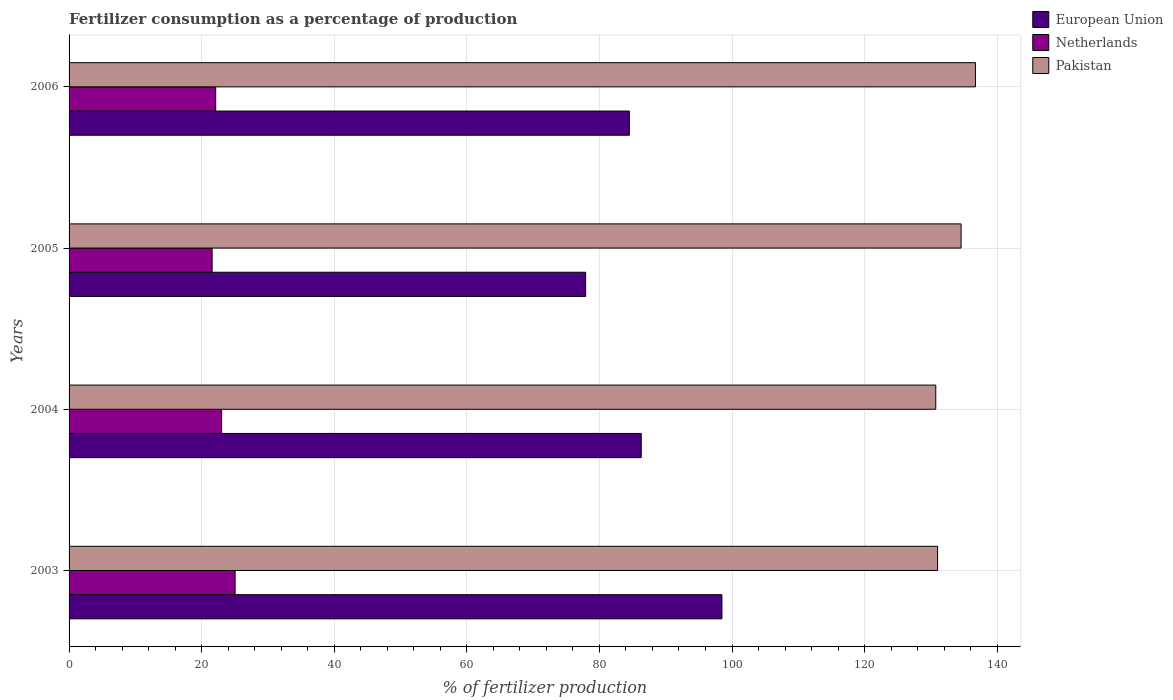How many different coloured bars are there?
Keep it short and to the point. 3. How many groups of bars are there?
Keep it short and to the point. 4. Are the number of bars per tick equal to the number of legend labels?
Provide a succinct answer. Yes. How many bars are there on the 2nd tick from the top?
Ensure brevity in your answer.  3. How many bars are there on the 2nd tick from the bottom?
Ensure brevity in your answer.  3. What is the label of the 2nd group of bars from the top?
Provide a short and direct response. 2005. In how many cases, is the number of bars for a given year not equal to the number of legend labels?
Your response must be concise. 0. What is the percentage of fertilizers consumed in European Union in 2005?
Your response must be concise. 77.92. Across all years, what is the maximum percentage of fertilizers consumed in European Union?
Offer a terse response. 98.48. Across all years, what is the minimum percentage of fertilizers consumed in Netherlands?
Offer a terse response. 21.58. In which year was the percentage of fertilizers consumed in Pakistan maximum?
Provide a succinct answer. 2006. In which year was the percentage of fertilizers consumed in Pakistan minimum?
Your response must be concise. 2004. What is the total percentage of fertilizers consumed in Pakistan in the graph?
Your response must be concise. 533.02. What is the difference between the percentage of fertilizers consumed in Netherlands in 2003 and that in 2004?
Your answer should be very brief. 2.04. What is the difference between the percentage of fertilizers consumed in Netherlands in 2005 and the percentage of fertilizers consumed in European Union in 2003?
Your answer should be compact. -76.9. What is the average percentage of fertilizers consumed in Pakistan per year?
Give a very brief answer. 133.26. In the year 2004, what is the difference between the percentage of fertilizers consumed in Pakistan and percentage of fertilizers consumed in European Union?
Make the answer very short. 44.43. What is the ratio of the percentage of fertilizers consumed in Pakistan in 2003 to that in 2006?
Your answer should be compact. 0.96. Is the percentage of fertilizers consumed in Pakistan in 2004 less than that in 2006?
Give a very brief answer. Yes. Is the difference between the percentage of fertilizers consumed in Pakistan in 2005 and 2006 greater than the difference between the percentage of fertilizers consumed in European Union in 2005 and 2006?
Offer a very short reply. Yes. What is the difference between the highest and the second highest percentage of fertilizers consumed in Pakistan?
Provide a short and direct response. 2.16. What is the difference between the highest and the lowest percentage of fertilizers consumed in Pakistan?
Make the answer very short. 5.99. In how many years, is the percentage of fertilizers consumed in Netherlands greater than the average percentage of fertilizers consumed in Netherlands taken over all years?
Your answer should be compact. 2. What does the 1st bar from the bottom in 2006 represents?
Provide a succinct answer. European Union. Are all the bars in the graph horizontal?
Offer a terse response. Yes. How many years are there in the graph?
Your answer should be very brief. 4. Does the graph contain any zero values?
Give a very brief answer. No. How are the legend labels stacked?
Provide a succinct answer. Vertical. What is the title of the graph?
Offer a terse response. Fertilizer consumption as a percentage of production. What is the label or title of the X-axis?
Offer a very short reply. % of fertilizer production. What is the % of fertilizer production of European Union in 2003?
Provide a short and direct response. 98.48. What is the % of fertilizer production in Netherlands in 2003?
Your answer should be very brief. 25.04. What is the % of fertilizer production of Pakistan in 2003?
Your answer should be very brief. 131.01. What is the % of fertilizer production in European Union in 2004?
Offer a terse response. 86.31. What is the % of fertilizer production in Netherlands in 2004?
Your response must be concise. 23.01. What is the % of fertilizer production of Pakistan in 2004?
Make the answer very short. 130.73. What is the % of fertilizer production in European Union in 2005?
Keep it short and to the point. 77.92. What is the % of fertilizer production in Netherlands in 2005?
Your response must be concise. 21.58. What is the % of fertilizer production of Pakistan in 2005?
Ensure brevity in your answer.  134.56. What is the % of fertilizer production in European Union in 2006?
Give a very brief answer. 84.51. What is the % of fertilizer production of Netherlands in 2006?
Offer a very short reply. 22.12. What is the % of fertilizer production in Pakistan in 2006?
Offer a terse response. 136.72. Across all years, what is the maximum % of fertilizer production of European Union?
Your answer should be very brief. 98.48. Across all years, what is the maximum % of fertilizer production of Netherlands?
Your response must be concise. 25.04. Across all years, what is the maximum % of fertilizer production in Pakistan?
Keep it short and to the point. 136.72. Across all years, what is the minimum % of fertilizer production of European Union?
Give a very brief answer. 77.92. Across all years, what is the minimum % of fertilizer production in Netherlands?
Provide a succinct answer. 21.58. Across all years, what is the minimum % of fertilizer production in Pakistan?
Ensure brevity in your answer.  130.73. What is the total % of fertilizer production in European Union in the graph?
Provide a succinct answer. 347.22. What is the total % of fertilizer production of Netherlands in the graph?
Provide a succinct answer. 91.75. What is the total % of fertilizer production in Pakistan in the graph?
Offer a very short reply. 533.02. What is the difference between the % of fertilizer production of European Union in 2003 and that in 2004?
Provide a succinct answer. 12.17. What is the difference between the % of fertilizer production in Netherlands in 2003 and that in 2004?
Give a very brief answer. 2.04. What is the difference between the % of fertilizer production in Pakistan in 2003 and that in 2004?
Offer a terse response. 0.28. What is the difference between the % of fertilizer production of European Union in 2003 and that in 2005?
Give a very brief answer. 20.56. What is the difference between the % of fertilizer production in Netherlands in 2003 and that in 2005?
Your answer should be very brief. 3.47. What is the difference between the % of fertilizer production of Pakistan in 2003 and that in 2005?
Your response must be concise. -3.55. What is the difference between the % of fertilizer production in European Union in 2003 and that in 2006?
Make the answer very short. 13.97. What is the difference between the % of fertilizer production in Netherlands in 2003 and that in 2006?
Provide a succinct answer. 2.92. What is the difference between the % of fertilizer production of Pakistan in 2003 and that in 2006?
Provide a succinct answer. -5.71. What is the difference between the % of fertilizer production of European Union in 2004 and that in 2005?
Keep it short and to the point. 8.39. What is the difference between the % of fertilizer production in Netherlands in 2004 and that in 2005?
Provide a succinct answer. 1.43. What is the difference between the % of fertilizer production of Pakistan in 2004 and that in 2005?
Your answer should be very brief. -3.82. What is the difference between the % of fertilizer production of European Union in 2004 and that in 2006?
Your answer should be compact. 1.8. What is the difference between the % of fertilizer production of Netherlands in 2004 and that in 2006?
Provide a succinct answer. 0.89. What is the difference between the % of fertilizer production of Pakistan in 2004 and that in 2006?
Offer a terse response. -5.99. What is the difference between the % of fertilizer production of European Union in 2005 and that in 2006?
Offer a terse response. -6.6. What is the difference between the % of fertilizer production of Netherlands in 2005 and that in 2006?
Offer a very short reply. -0.54. What is the difference between the % of fertilizer production of Pakistan in 2005 and that in 2006?
Provide a short and direct response. -2.16. What is the difference between the % of fertilizer production in European Union in 2003 and the % of fertilizer production in Netherlands in 2004?
Offer a very short reply. 75.47. What is the difference between the % of fertilizer production in European Union in 2003 and the % of fertilizer production in Pakistan in 2004?
Your response must be concise. -32.26. What is the difference between the % of fertilizer production of Netherlands in 2003 and the % of fertilizer production of Pakistan in 2004?
Keep it short and to the point. -105.69. What is the difference between the % of fertilizer production in European Union in 2003 and the % of fertilizer production in Netherlands in 2005?
Your answer should be very brief. 76.9. What is the difference between the % of fertilizer production of European Union in 2003 and the % of fertilizer production of Pakistan in 2005?
Your answer should be very brief. -36.08. What is the difference between the % of fertilizer production in Netherlands in 2003 and the % of fertilizer production in Pakistan in 2005?
Make the answer very short. -109.51. What is the difference between the % of fertilizer production of European Union in 2003 and the % of fertilizer production of Netherlands in 2006?
Keep it short and to the point. 76.36. What is the difference between the % of fertilizer production in European Union in 2003 and the % of fertilizer production in Pakistan in 2006?
Make the answer very short. -38.24. What is the difference between the % of fertilizer production of Netherlands in 2003 and the % of fertilizer production of Pakistan in 2006?
Make the answer very short. -111.68. What is the difference between the % of fertilizer production of European Union in 2004 and the % of fertilizer production of Netherlands in 2005?
Your response must be concise. 64.73. What is the difference between the % of fertilizer production in European Union in 2004 and the % of fertilizer production in Pakistan in 2005?
Offer a very short reply. -48.25. What is the difference between the % of fertilizer production in Netherlands in 2004 and the % of fertilizer production in Pakistan in 2005?
Give a very brief answer. -111.55. What is the difference between the % of fertilizer production of European Union in 2004 and the % of fertilizer production of Netherlands in 2006?
Offer a very short reply. 64.19. What is the difference between the % of fertilizer production in European Union in 2004 and the % of fertilizer production in Pakistan in 2006?
Your response must be concise. -50.41. What is the difference between the % of fertilizer production of Netherlands in 2004 and the % of fertilizer production of Pakistan in 2006?
Keep it short and to the point. -113.71. What is the difference between the % of fertilizer production in European Union in 2005 and the % of fertilizer production in Netherlands in 2006?
Provide a short and direct response. 55.8. What is the difference between the % of fertilizer production of European Union in 2005 and the % of fertilizer production of Pakistan in 2006?
Your answer should be compact. -58.8. What is the difference between the % of fertilizer production of Netherlands in 2005 and the % of fertilizer production of Pakistan in 2006?
Provide a succinct answer. -115.14. What is the average % of fertilizer production of European Union per year?
Ensure brevity in your answer.  86.8. What is the average % of fertilizer production in Netherlands per year?
Keep it short and to the point. 22.94. What is the average % of fertilizer production of Pakistan per year?
Your response must be concise. 133.26. In the year 2003, what is the difference between the % of fertilizer production of European Union and % of fertilizer production of Netherlands?
Provide a succinct answer. 73.43. In the year 2003, what is the difference between the % of fertilizer production in European Union and % of fertilizer production in Pakistan?
Provide a succinct answer. -32.53. In the year 2003, what is the difference between the % of fertilizer production in Netherlands and % of fertilizer production in Pakistan?
Your answer should be very brief. -105.97. In the year 2004, what is the difference between the % of fertilizer production of European Union and % of fertilizer production of Netherlands?
Ensure brevity in your answer.  63.3. In the year 2004, what is the difference between the % of fertilizer production in European Union and % of fertilizer production in Pakistan?
Provide a succinct answer. -44.43. In the year 2004, what is the difference between the % of fertilizer production in Netherlands and % of fertilizer production in Pakistan?
Provide a short and direct response. -107.73. In the year 2005, what is the difference between the % of fertilizer production of European Union and % of fertilizer production of Netherlands?
Provide a short and direct response. 56.34. In the year 2005, what is the difference between the % of fertilizer production in European Union and % of fertilizer production in Pakistan?
Provide a short and direct response. -56.64. In the year 2005, what is the difference between the % of fertilizer production in Netherlands and % of fertilizer production in Pakistan?
Provide a short and direct response. -112.98. In the year 2006, what is the difference between the % of fertilizer production of European Union and % of fertilizer production of Netherlands?
Provide a short and direct response. 62.39. In the year 2006, what is the difference between the % of fertilizer production in European Union and % of fertilizer production in Pakistan?
Give a very brief answer. -52.21. In the year 2006, what is the difference between the % of fertilizer production of Netherlands and % of fertilizer production of Pakistan?
Provide a short and direct response. -114.6. What is the ratio of the % of fertilizer production in European Union in 2003 to that in 2004?
Give a very brief answer. 1.14. What is the ratio of the % of fertilizer production of Netherlands in 2003 to that in 2004?
Make the answer very short. 1.09. What is the ratio of the % of fertilizer production in European Union in 2003 to that in 2005?
Offer a very short reply. 1.26. What is the ratio of the % of fertilizer production of Netherlands in 2003 to that in 2005?
Provide a succinct answer. 1.16. What is the ratio of the % of fertilizer production in Pakistan in 2003 to that in 2005?
Give a very brief answer. 0.97. What is the ratio of the % of fertilizer production in European Union in 2003 to that in 2006?
Offer a very short reply. 1.17. What is the ratio of the % of fertilizer production of Netherlands in 2003 to that in 2006?
Your response must be concise. 1.13. What is the ratio of the % of fertilizer production in Pakistan in 2003 to that in 2006?
Offer a terse response. 0.96. What is the ratio of the % of fertilizer production in European Union in 2004 to that in 2005?
Your answer should be compact. 1.11. What is the ratio of the % of fertilizer production in Netherlands in 2004 to that in 2005?
Make the answer very short. 1.07. What is the ratio of the % of fertilizer production in Pakistan in 2004 to that in 2005?
Keep it short and to the point. 0.97. What is the ratio of the % of fertilizer production in European Union in 2004 to that in 2006?
Make the answer very short. 1.02. What is the ratio of the % of fertilizer production of Netherlands in 2004 to that in 2006?
Offer a terse response. 1.04. What is the ratio of the % of fertilizer production in Pakistan in 2004 to that in 2006?
Your answer should be very brief. 0.96. What is the ratio of the % of fertilizer production of European Union in 2005 to that in 2006?
Offer a very short reply. 0.92. What is the ratio of the % of fertilizer production of Netherlands in 2005 to that in 2006?
Keep it short and to the point. 0.98. What is the ratio of the % of fertilizer production of Pakistan in 2005 to that in 2006?
Your answer should be compact. 0.98. What is the difference between the highest and the second highest % of fertilizer production of European Union?
Provide a short and direct response. 12.17. What is the difference between the highest and the second highest % of fertilizer production in Netherlands?
Your answer should be compact. 2.04. What is the difference between the highest and the second highest % of fertilizer production of Pakistan?
Keep it short and to the point. 2.16. What is the difference between the highest and the lowest % of fertilizer production of European Union?
Your answer should be compact. 20.56. What is the difference between the highest and the lowest % of fertilizer production in Netherlands?
Your answer should be compact. 3.47. What is the difference between the highest and the lowest % of fertilizer production in Pakistan?
Keep it short and to the point. 5.99. 